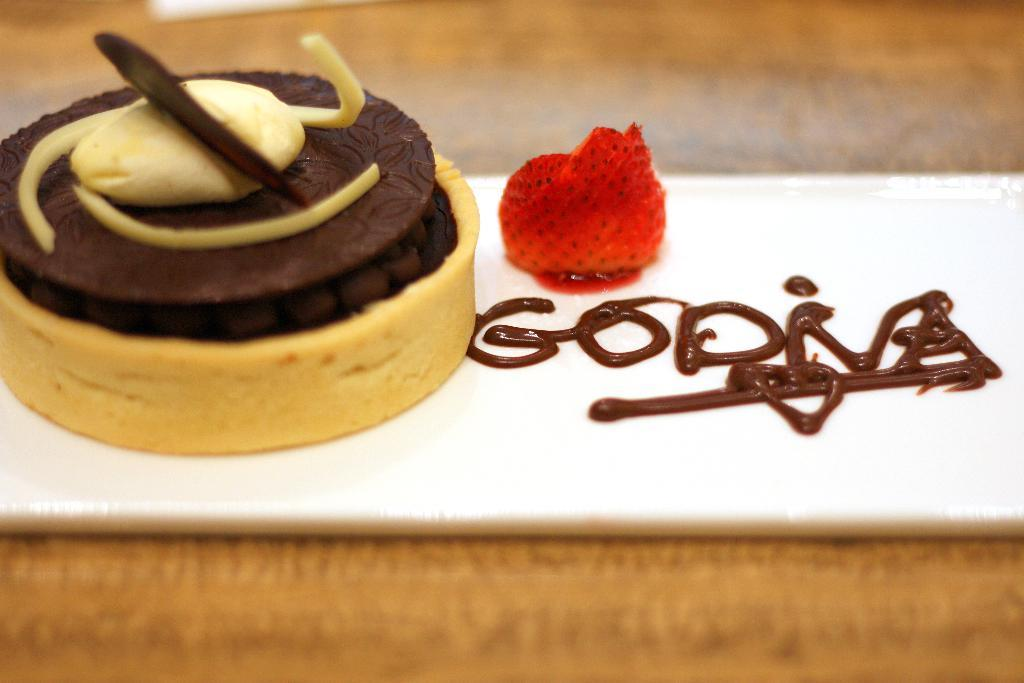What is the main piece of furniture in the image? There is a table in the image. What is placed on the table? There is a tray on the table. What is on the tray? The tray contains cake, strawberries, and melted chocolate cream. What type of organization is responsible for the coal in the image? There is no coal present in the image. Can you introduce me to the friend who is eating the cake in the image? There is no person, including a friend, present in the image. 